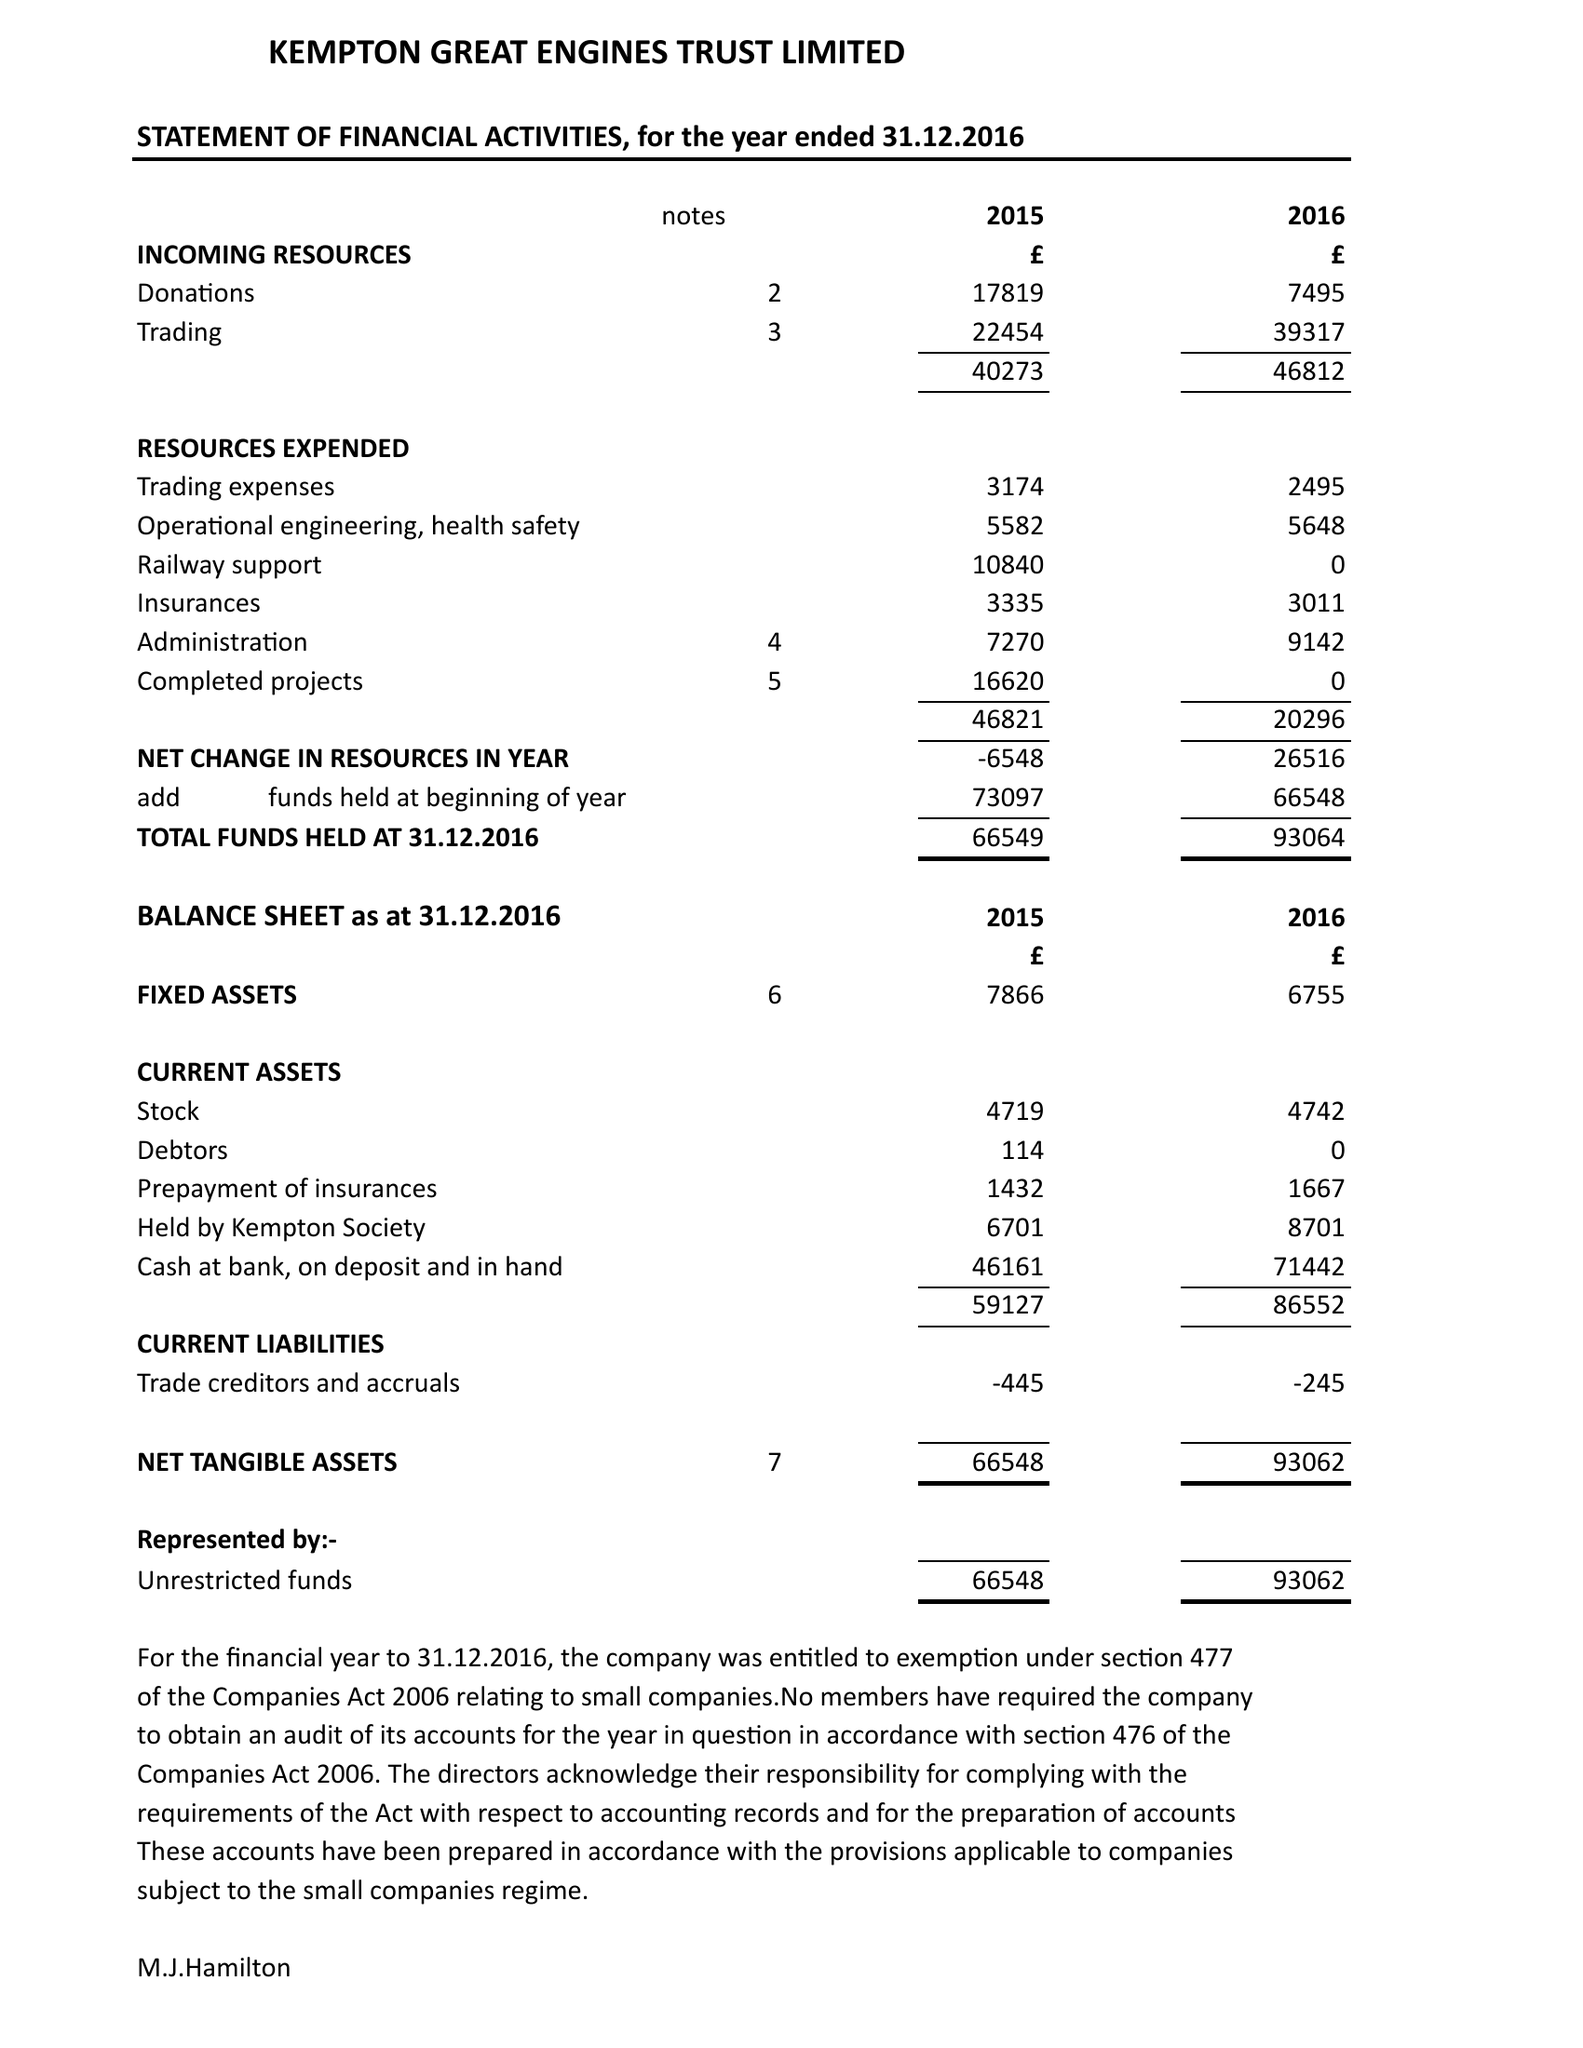What is the value for the spending_annually_in_british_pounds?
Answer the question using a single word or phrase. 20296.00 